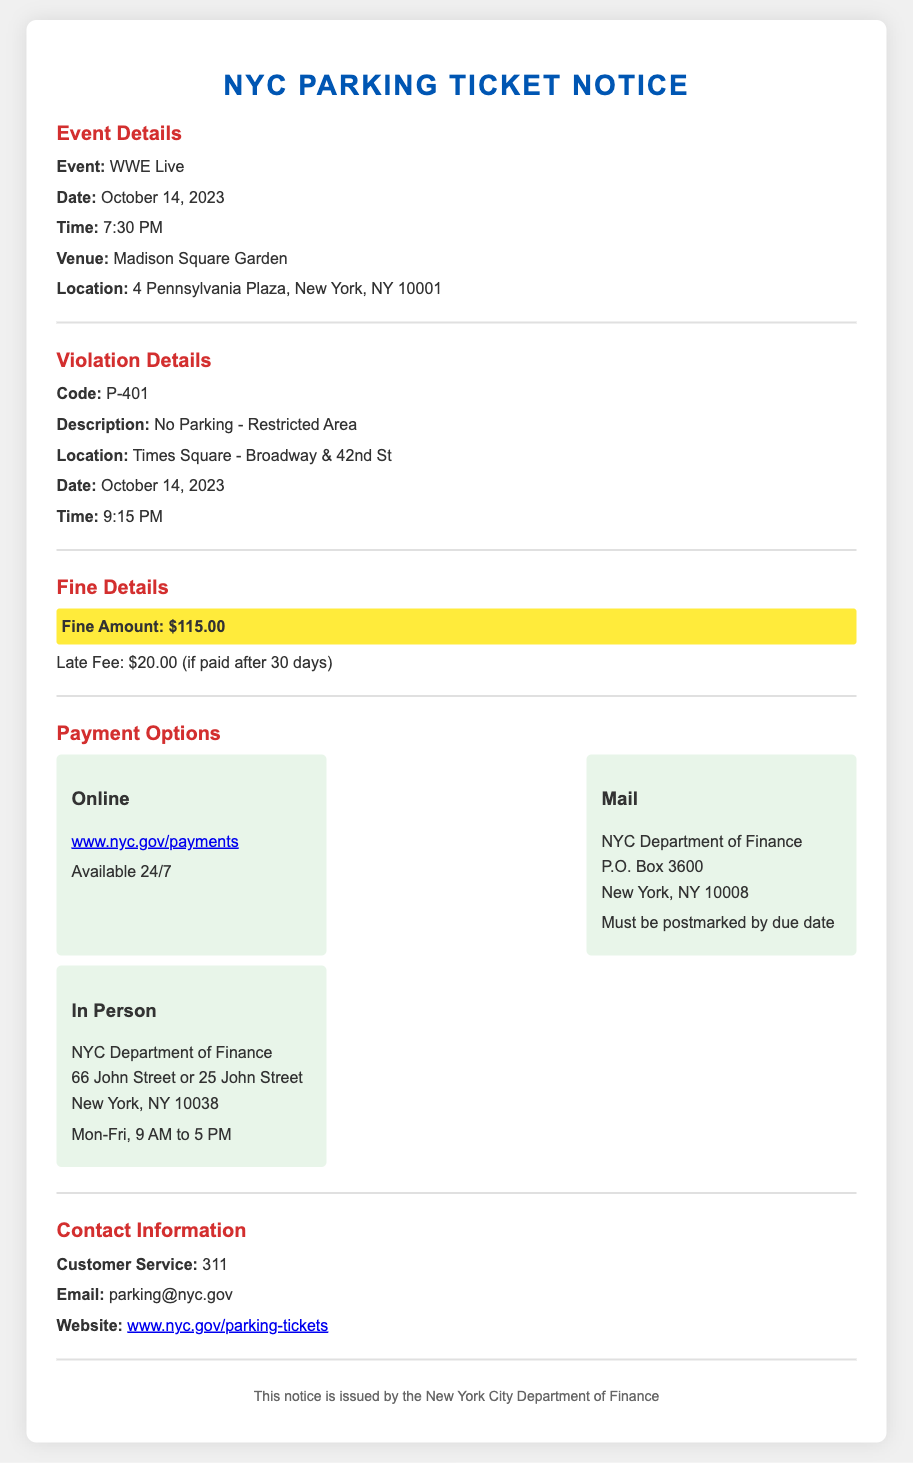What is the event name? The event name is clearly mentioned in the document as "WWE Live".
Answer: WWE Live When was the parking ticket issued? The document states the date of the violation occurred as "October 14, 2023".
Answer: October 14, 2023 What is the fine amount for the violation? The fine amount is highlighted in the section dedicated to fine details, which states "$115.00".
Answer: $115.00 Where can payments be made online? The document provides a link for online payments, noted as "www.nyc.gov/payments".
Answer: www.nyc.gov/payments What is the late fee amount? The late fee information is provided under fine details, stating "Late Fee: $20.00 (if paid after 30 days)".
Answer: $20.00 What is the location of the violation? The location of the violation is listed in the violation details, which mentions "Times Square - Broadway & 42nd St".
Answer: Times Square - Broadway & 42nd St What are the hours for in-person payments? The document specifies the hours for in-person payments as "Mon-Fri, 9 AM to 5 PM".
Answer: Mon-Fri, 9 AM to 5 PM Who should be contacted for customer service? The document indicates that customer service can be reached by calling "311".
Answer: 311 What is the description of the parking violation? The description of the violation is provided in the violation details section, which states "No Parking - Restricted Area".
Answer: No Parking - Restricted Area 